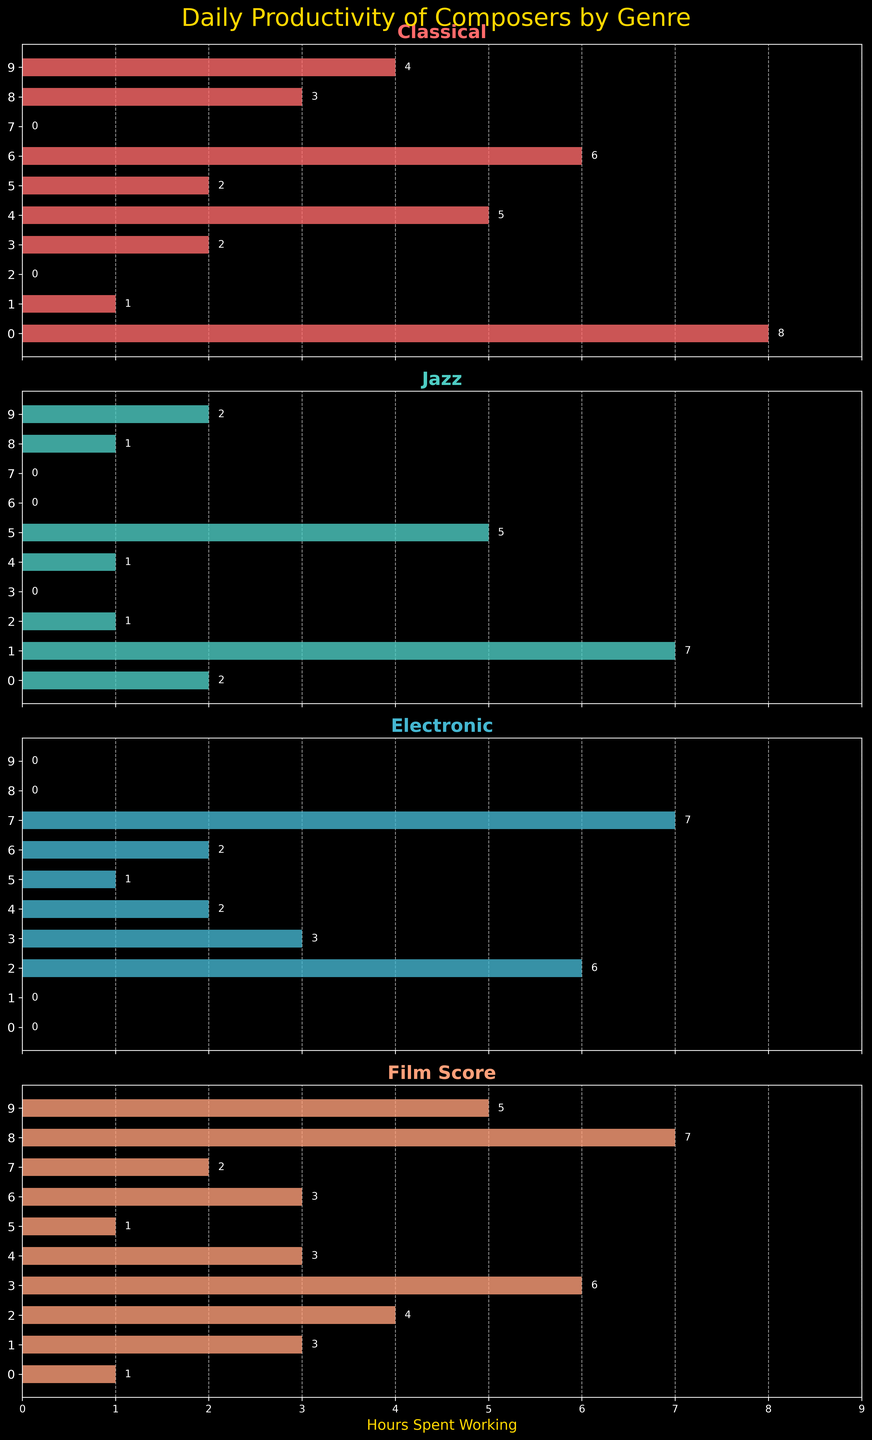What is the title of the figure? The title is prominently displayed at the top of the figure.
Answer: Daily Productivity of Composers by Genre Which genre does Johann Sebastian Bach spend the most time on? By looking at the segment for Johann Sebastian Bach across the different subplots, it's clear he spends the most time on Classical music with 8 hours.
Answer: Classical How many composers are plotted in total? Count the number of y-tick labels on any of the subplots to determine the total number of composers. There are 10 composers listed.
Answer: 10 Which composer spends the least time on Jazz? Identify the shortest bars in the Jazz subplot and cross-check with the labels. Aphex Twin and Ludovico Einaudi both spend 0 hours on Jazz.
Answer: Aphex Twin and Ludovico Einaudi Who spends the most time working on Film Scores? Find the longest bar in the Film Score subplot and check the corresponding composer label. John Williams works the most with 7 hours spent.
Answer: John Williams What is the combined total time spent by Hans Zimmer across all genres? Add the hours spent by Hans Zimmer in each genre: 2 (Classical) + 0 (Jazz) + 3 (Electronic) + 6 (Film Score).
Answer: 11 hours Between Norah Jones and Yann Tiersen, who spends more time on Jazz? Compare the bars for Norah Jones and Yann Tiersen in the Jazz subplot. Norah Jones spends more time with 5 hours.
Answer: Norah Jones If we sum the hours spent on Classical by Johann Sebastian Bach and Ludovico Einaudi, what would be the total? Add the time Johann Sebastian Bach (8 hours) and Ludovico Einaudi (6 hours) spend on Classical.
Answer: 14 hours Which genre has the highest productivity for Daft Punk? By scanning the subplots, it's clear the longest bar for Daft Punk is in the Electronic genre with 6 hours.
Answer: Electronic How many hours does Miles Davis spend on genres other than Jazz? Subtract the time Miles Davis spends on Jazz from his total: 1 (Classical) + 0 (Electronic) + 3 (Film Score) = 4 hours.
Answer: 4 hours What is the range of hours spent on Classical music? In the Classical subplot, the maximum is 8 hours (Johann Sebastian Bach), and the minimum is 0 hours (Daft Punk, Aphex Twin). The range is 8 - 0 = 8 hours.
Answer: 8 hours 